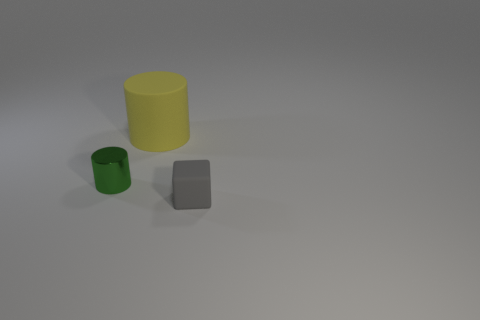Add 1 large cylinders. How many objects exist? 4 Subtract all cylinders. How many objects are left? 1 Subtract all large blue matte cylinders. Subtract all yellow matte things. How many objects are left? 2 Add 2 green cylinders. How many green cylinders are left? 3 Add 3 big yellow objects. How many big yellow objects exist? 4 Subtract 0 yellow blocks. How many objects are left? 3 